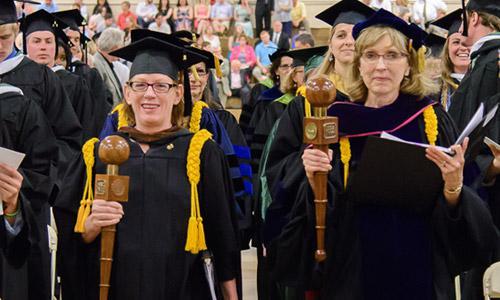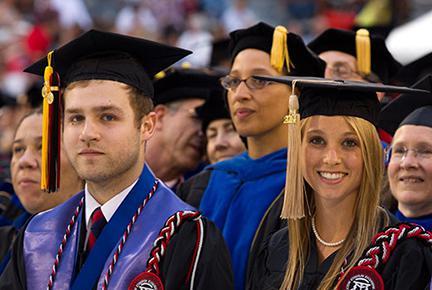The first image is the image on the left, the second image is the image on the right. Analyze the images presented: Is the assertion "Some of the people's tassels on their hats are yellow." valid? Answer yes or no. Yes. The first image is the image on the left, the second image is the image on the right. Analyze the images presented: Is the assertion "There are at most two graduates in the left image." valid? Answer yes or no. No. 